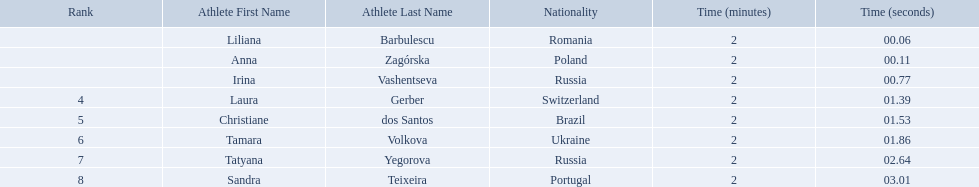Which athletes competed in the 2003 summer universiade - women's 800 metres? Liliana Barbulescu, Anna Zagórska, Irina Vashentseva, Laura Gerber, Christiane dos Santos, Tamara Volkova, Tatyana Yegorova, Sandra Teixeira. Of these, which are from poland? Anna Zagórska. What is her time? 2:00.11. What were all the finishing times? 2:00.06, 2:00.11, 2:00.77, 2:01.39, 2:01.53, 2:01.86, 2:02.64, 2:03.01. Which of these is anna zagorska's? 2:00.11. Parse the full table in json format. {'header': ['Rank', 'Athlete First Name', 'Athlete Last Name', 'Nationality', 'Time (minutes)', 'Time (seconds)'], 'rows': [['', 'Liliana', 'Barbulescu', 'Romania', '2', '00.06'], ['', 'Anna', 'Zagórska', 'Poland', '2', '00.11'], ['', 'Irina', 'Vashentseva', 'Russia', '2', '00.77'], ['4', 'Laura', 'Gerber', 'Switzerland', '2', '01.39'], ['5', 'Christiane', 'dos Santos', 'Brazil', '2', '01.53'], ['6', 'Tamara', 'Volkova', 'Ukraine', '2', '01.86'], ['7', 'Tatyana', 'Yegorova', 'Russia', '2', '02.64'], ['8', 'Sandra', 'Teixeira', 'Portugal', '2', '03.01']]} 